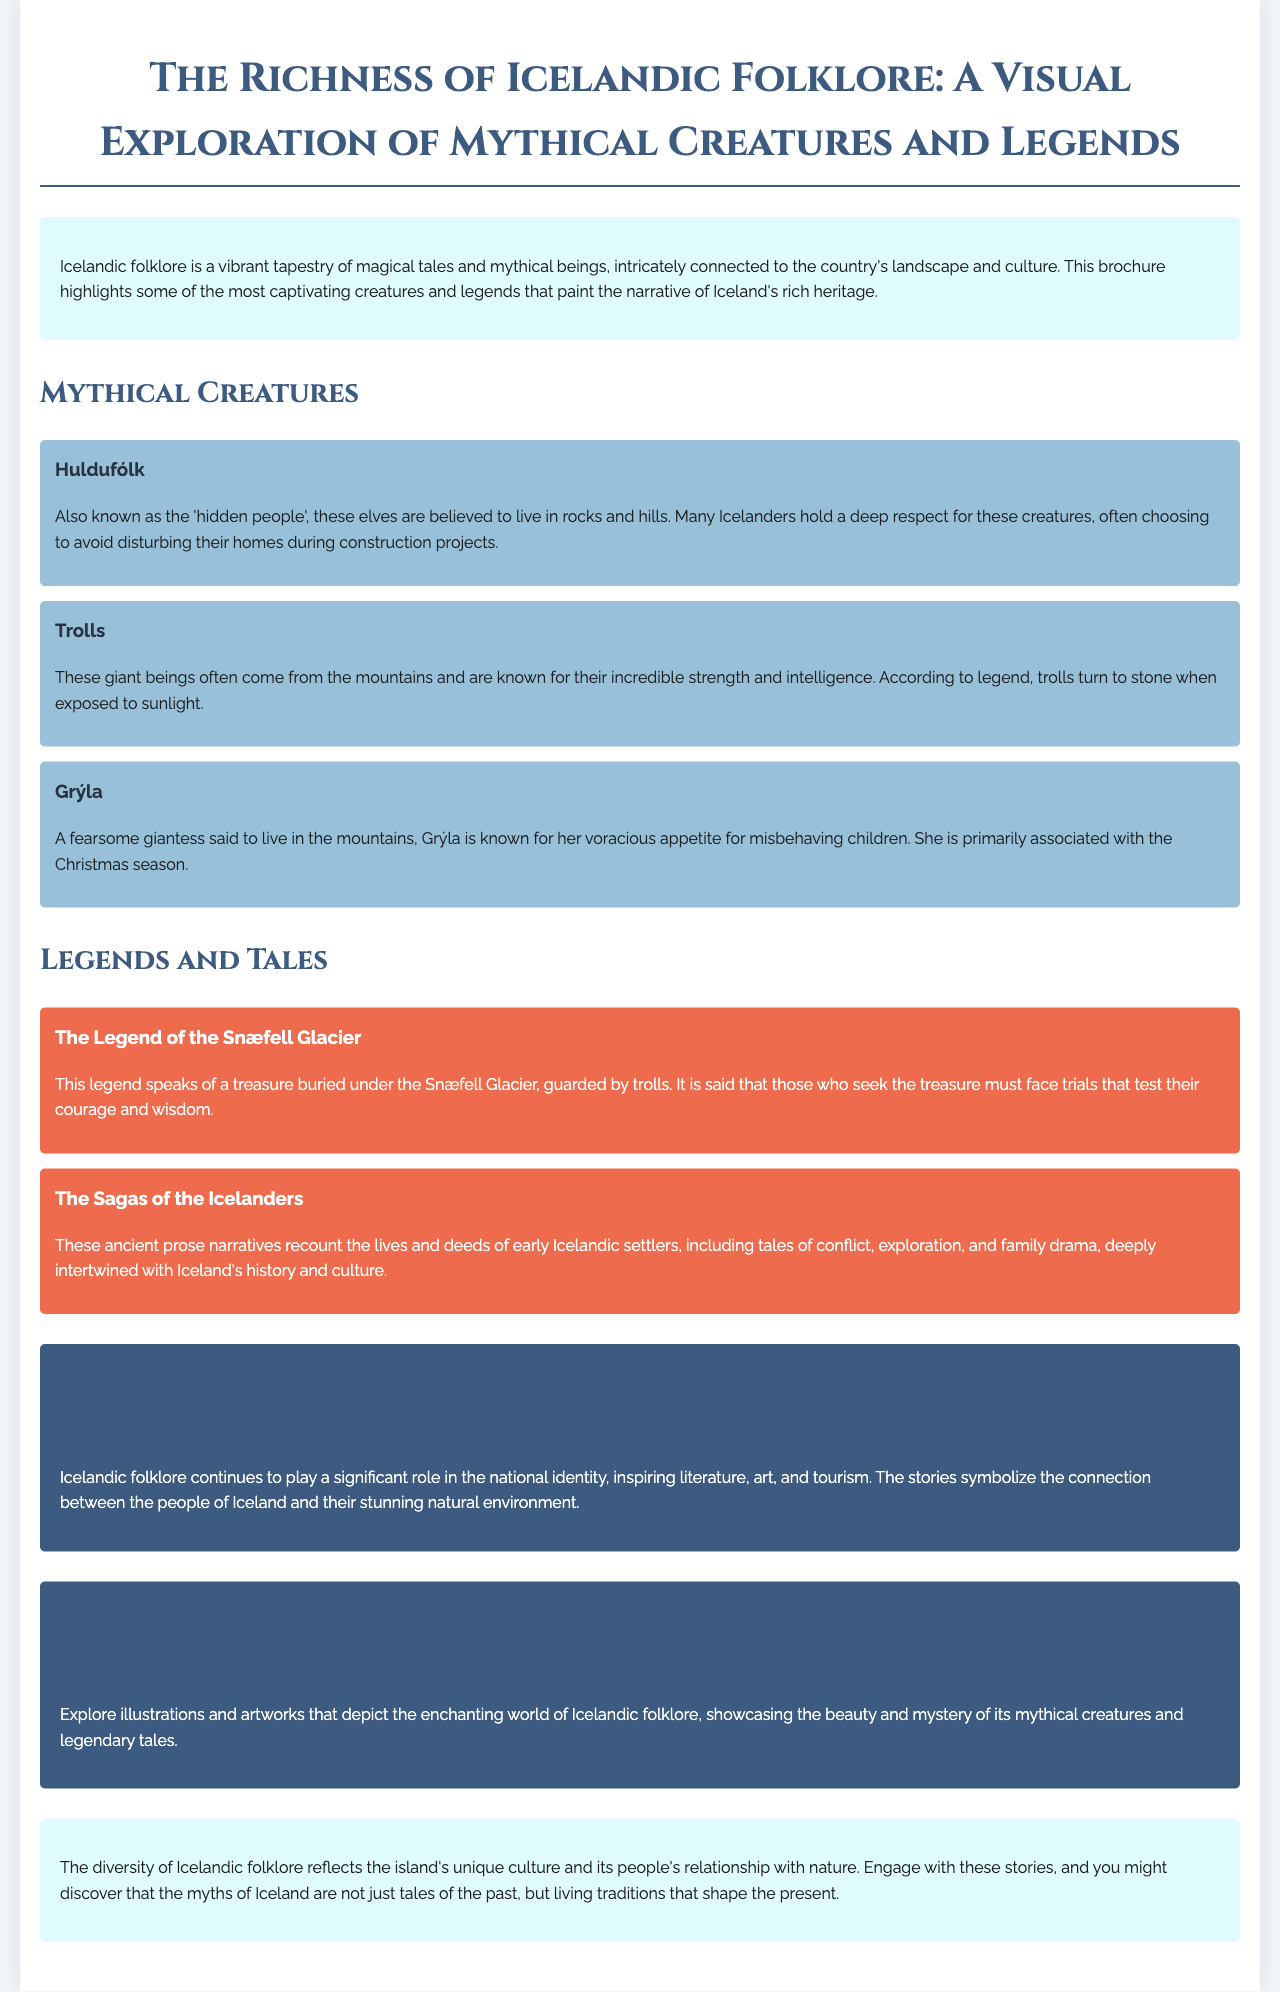What is the title of the brochure? The title is presented prominently at the top of the document.
Answer: The Richness of Icelandic Folklore: A Visual Exploration of Mythical Creatures and Legends Who are the 'hidden people'? The document describes a specific group within Icelandic folklore.
Answer: Huldufólk What is Grýla known for? The document explains the specific characteristic associated with Grýla.
Answer: Voracious appetite for misbehaving children What legend speaks of a treasure under the Snæfell Glacier? The document names specific legends found within Icelandic folklore.
Answer: The Legend of the Snæfell Glacier How do trolls allegedly react to sunlight? The document provides a unique trait regarding trolls.
Answer: Turn to stone What do the sagas of the Icelanders recount? The document explains what the sagas cover about Icelandic history.
Answer: Lives and deeds of early Icelandic settlers What is the significance of Icelandic folklore according to the brochure? The document discusses the broader importance of folklore in Icelandic culture.
Answer: National identity What type of content does the visual representation section encourage exploring? The document specifies the nature of the visual content related to folklore.
Answer: Illustrations and artworks 